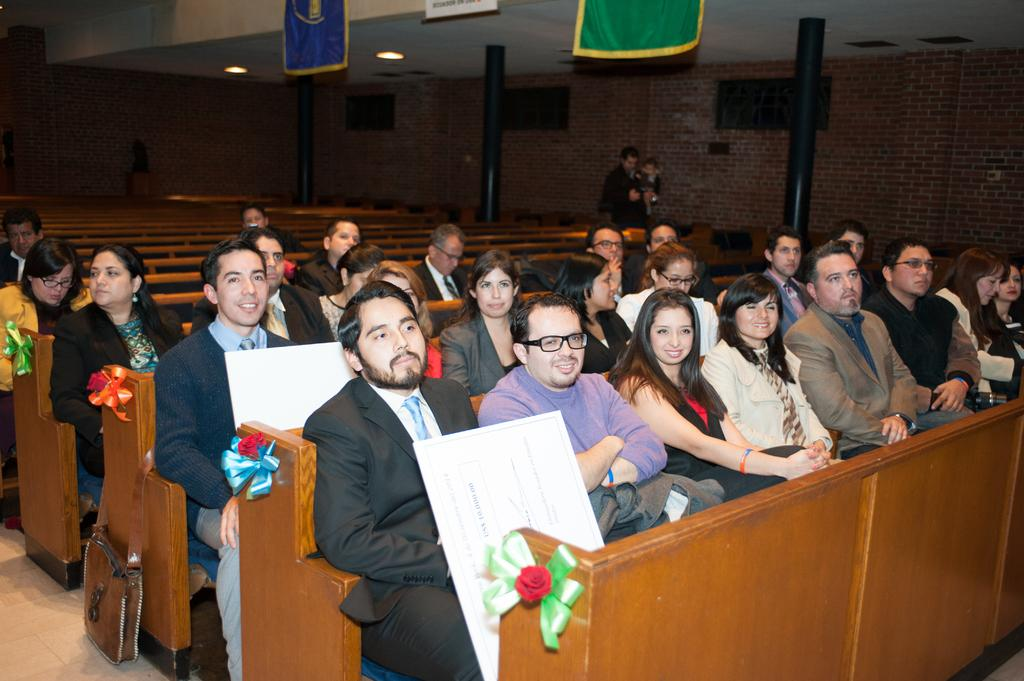What are the people in the image doing? The people in the image are sitting on tables in the center of the image. What can be seen in the background of the image? There is a wall and pillars in the background of the image. How many crates are stacked on top of each other in the image? There are no crates present in the image. What is the people's desire in the image? The image does not provide information about the people's desires. 